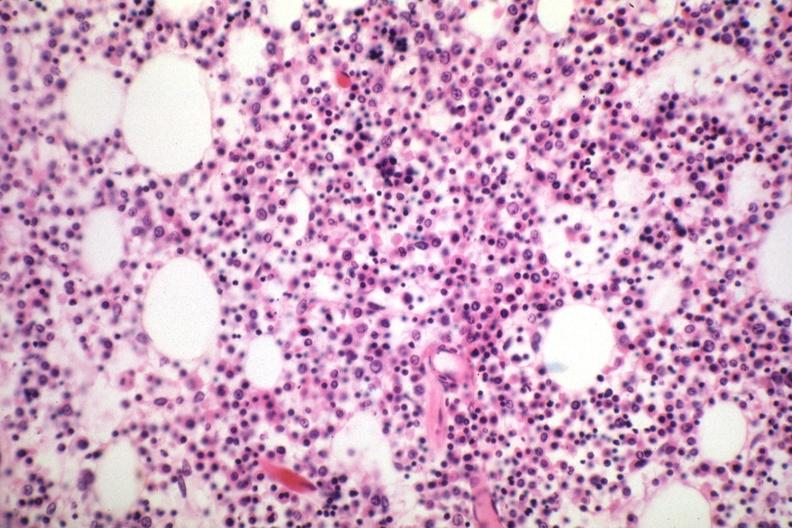what does this image show?
Answer the question using a single word or phrase. Marrow loaded with plasma cells that are immature 